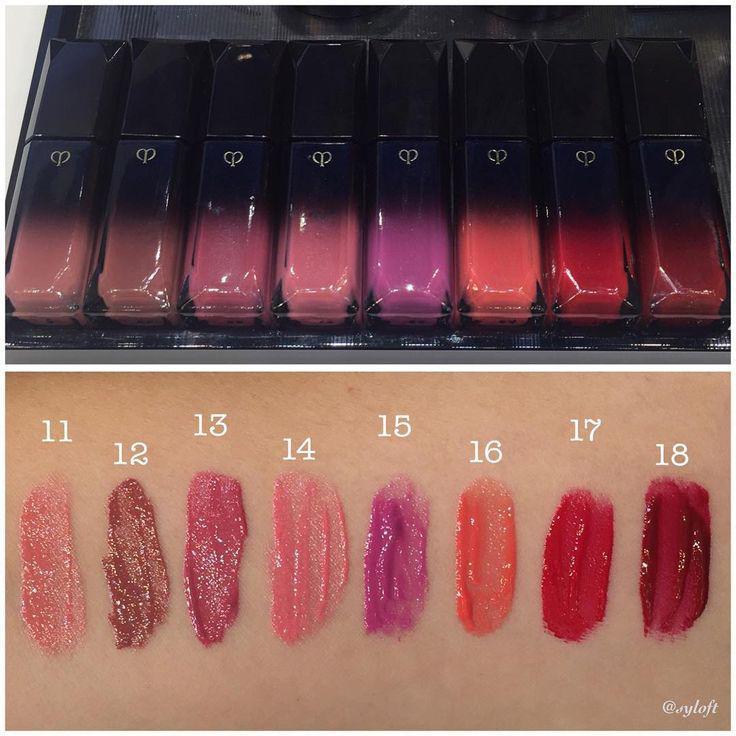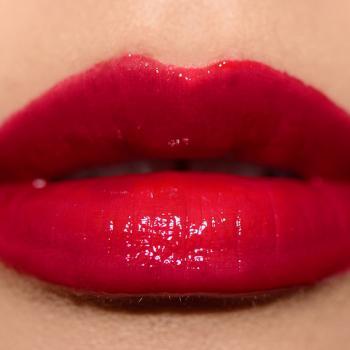The first image is the image on the left, the second image is the image on the right. Considering the images on both sides, is "The image on the right shows on pair of lips wearing makeup." valid? Answer yes or no. Yes. The first image is the image on the left, the second image is the image on the right. Examine the images to the left and right. Is the description "There are more than six pairs of lips in total." accurate? Answer yes or no. No. 